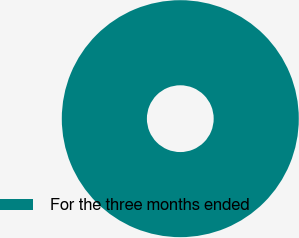<chart> <loc_0><loc_0><loc_500><loc_500><pie_chart><fcel>For the three months ended<nl><fcel>100.0%<nl></chart> 